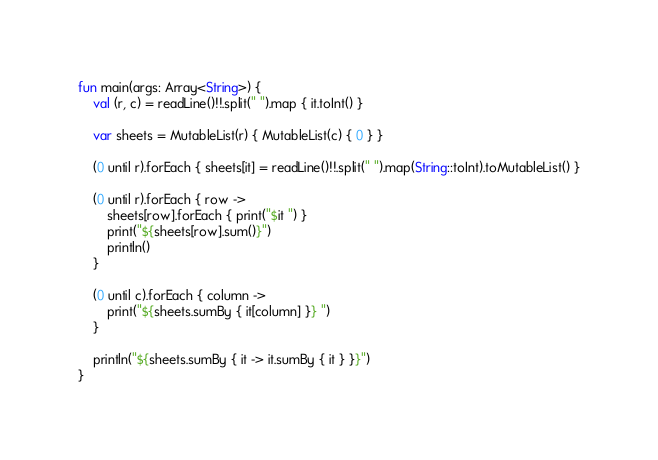Convert code to text. <code><loc_0><loc_0><loc_500><loc_500><_Kotlin_>fun main(args: Array<String>) {
    val (r, c) = readLine()!!.split(" ").map { it.toInt() }

    var sheets = MutableList(r) { MutableList(c) { 0 } }

    (0 until r).forEach { sheets[it] = readLine()!!.split(" ").map(String::toInt).toMutableList() }

    (0 until r).forEach { row ->
        sheets[row].forEach { print("$it ") }
        print("${sheets[row].sum()}")
        println()
    }

    (0 until c).forEach { column ->
        print("${sheets.sumBy { it[column] }} ")
    }

    println("${sheets.sumBy { it -> it.sumBy { it } }}")
}
</code> 